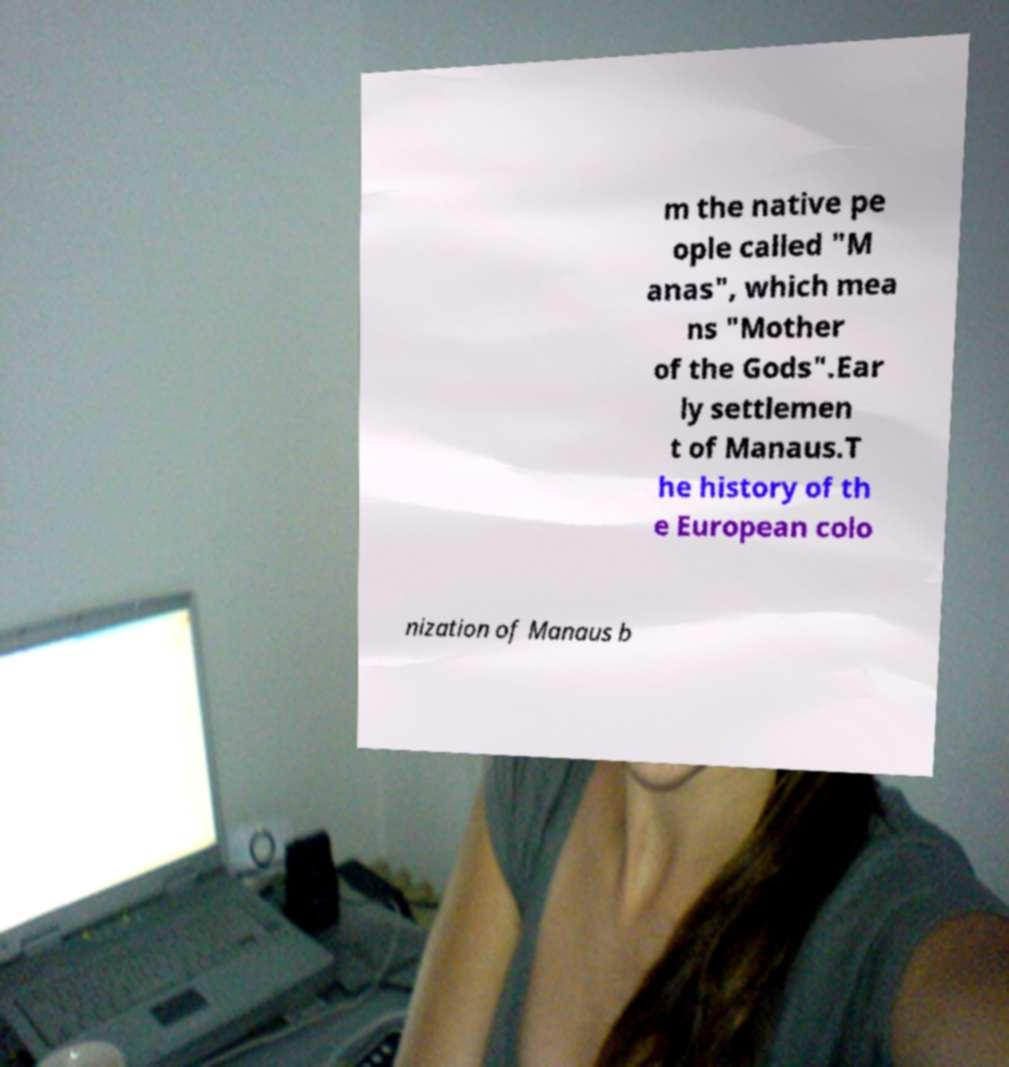I need the written content from this picture converted into text. Can you do that? m the native pe ople called "M anas", which mea ns "Mother of the Gods".Ear ly settlemen t of Manaus.T he history of th e European colo nization of Manaus b 